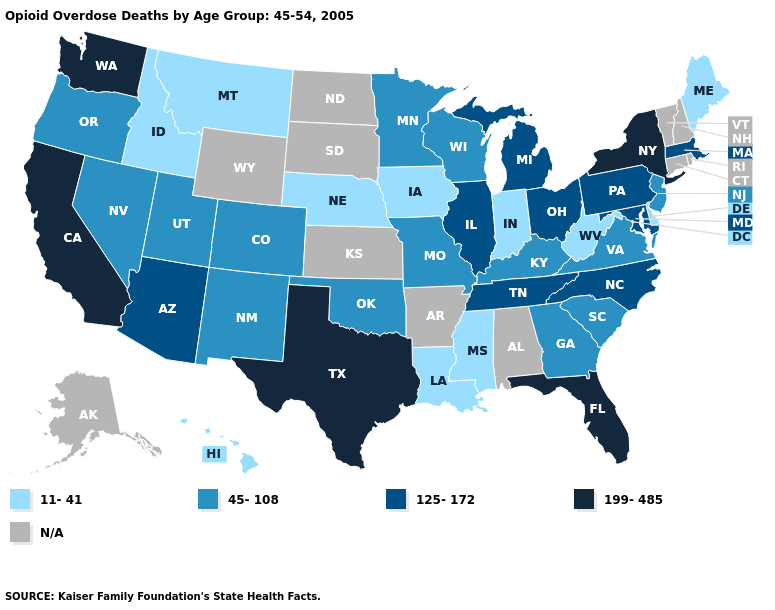How many symbols are there in the legend?
Be succinct. 5. How many symbols are there in the legend?
Write a very short answer. 5. Which states have the highest value in the USA?
Concise answer only. California, Florida, New York, Texas, Washington. What is the value of Michigan?
Give a very brief answer. 125-172. What is the value of Alaska?
Quick response, please. N/A. What is the value of Tennessee?
Answer briefly. 125-172. Which states have the lowest value in the USA?
Concise answer only. Delaware, Hawaii, Idaho, Indiana, Iowa, Louisiana, Maine, Mississippi, Montana, Nebraska, West Virginia. Name the states that have a value in the range 45-108?
Be succinct. Colorado, Georgia, Kentucky, Minnesota, Missouri, Nevada, New Jersey, New Mexico, Oklahoma, Oregon, South Carolina, Utah, Virginia, Wisconsin. Name the states that have a value in the range 199-485?
Write a very short answer. California, Florida, New York, Texas, Washington. What is the value of North Dakota?
Concise answer only. N/A. Name the states that have a value in the range 199-485?
Concise answer only. California, Florida, New York, Texas, Washington. Among the states that border Wyoming , does Colorado have the highest value?
Answer briefly. Yes. Among the states that border Tennessee , which have the highest value?
Concise answer only. North Carolina. 